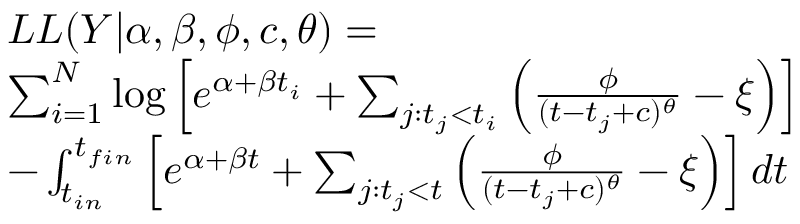Convert formula to latex. <formula><loc_0><loc_0><loc_500><loc_500>\begin{array} { r l } & { L L ( Y | \alpha , \beta , \phi , c , \theta ) = } \\ & { \sum _ { i = 1 } ^ { N } \log \left [ e ^ { \alpha + \beta t _ { i } } + \sum _ { j \colon t _ { j } < t _ { i } } \left ( \frac { \phi } { ( t - t _ { j } + c ) ^ { \theta } } - \xi \right ) \right ] } \\ & { - \int _ { t _ { i n } } ^ { t _ { f i n } } \left [ e ^ { \alpha + \beta t } + \sum _ { j \colon t _ { j } < t } \left ( \frac { \phi } { ( t - t _ { j } + c ) ^ { \theta } } - \xi \right ) \right ] d t } \end{array}</formula> 